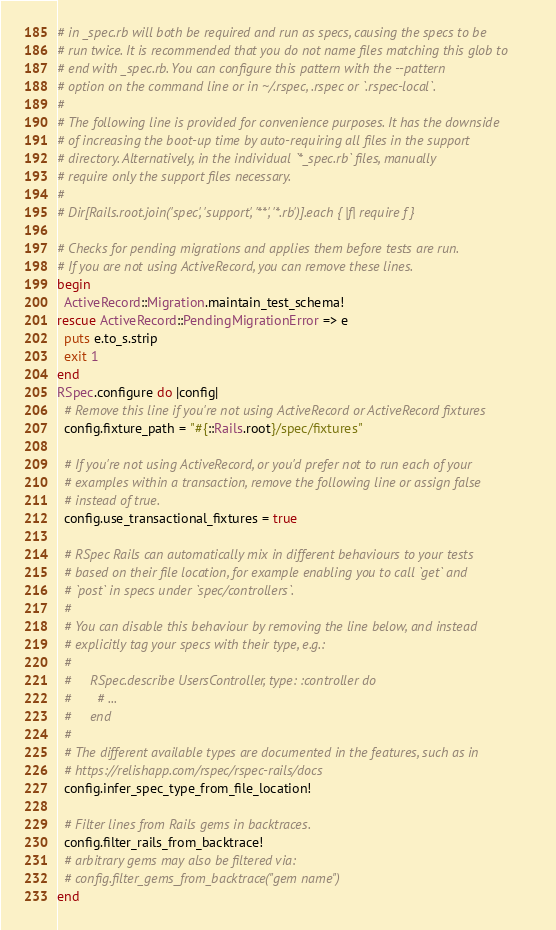<code> <loc_0><loc_0><loc_500><loc_500><_Ruby_># in _spec.rb will both be required and run as specs, causing the specs to be
# run twice. It is recommended that you do not name files matching this glob to
# end with _spec.rb. You can configure this pattern with the --pattern
# option on the command line or in ~/.rspec, .rspec or `.rspec-local`.
#
# The following line is provided for convenience purposes. It has the downside
# of increasing the boot-up time by auto-requiring all files in the support
# directory. Alternatively, in the individual `*_spec.rb` files, manually
# require only the support files necessary.
#
# Dir[Rails.root.join('spec', 'support', '**', '*.rb')].each { |f| require f }

# Checks for pending migrations and applies them before tests are run.
# If you are not using ActiveRecord, you can remove these lines.
begin
  ActiveRecord::Migration.maintain_test_schema!
rescue ActiveRecord::PendingMigrationError => e
  puts e.to_s.strip
  exit 1
end
RSpec.configure do |config|
  # Remove this line if you're not using ActiveRecord or ActiveRecord fixtures
  config.fixture_path = "#{::Rails.root}/spec/fixtures"

  # If you're not using ActiveRecord, or you'd prefer not to run each of your
  # examples within a transaction, remove the following line or assign false
  # instead of true.
  config.use_transactional_fixtures = true

  # RSpec Rails can automatically mix in different behaviours to your tests
  # based on their file location, for example enabling you to call `get` and
  # `post` in specs under `spec/controllers`.
  #
  # You can disable this behaviour by removing the line below, and instead
  # explicitly tag your specs with their type, e.g.:
  #
  #     RSpec.describe UsersController, type: :controller do
  #       # ...
  #     end
  #
  # The different available types are documented in the features, such as in
  # https://relishapp.com/rspec/rspec-rails/docs
  config.infer_spec_type_from_file_location!

  # Filter lines from Rails gems in backtraces.
  config.filter_rails_from_backtrace!
  # arbitrary gems may also be filtered via:
  # config.filter_gems_from_backtrace("gem name")
end
</code> 